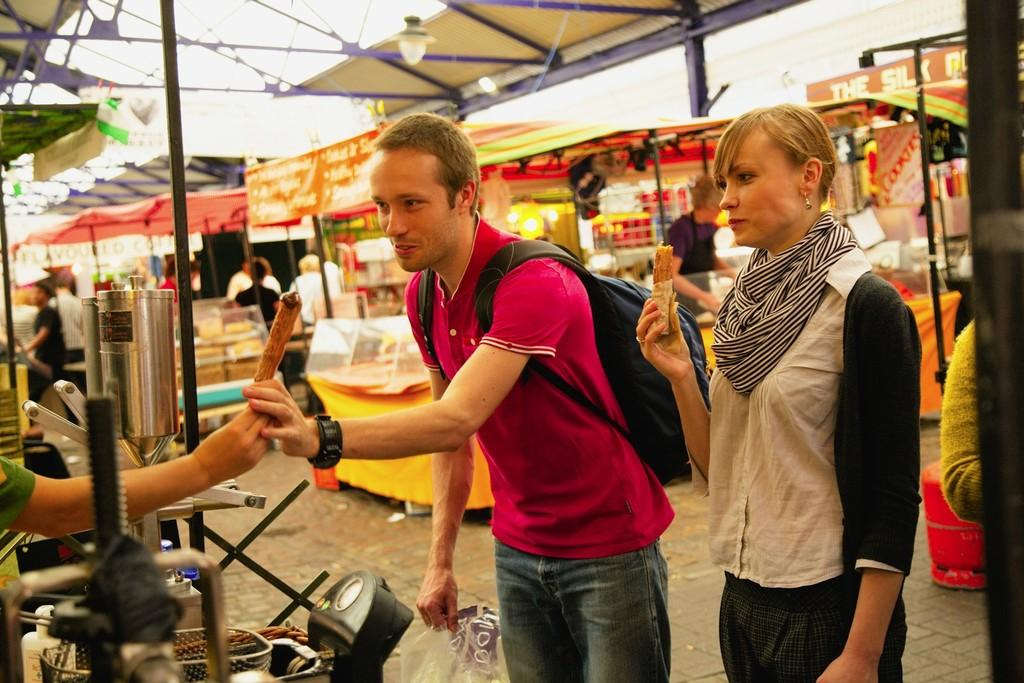What is the girl holding in the image? The girl is holding something named Frankie. What is happening between the girl and the boy in the image? The boy is taking Frankie from the girl's hand. What can be seen in the background of the image? There are food stalls visible in the background. What type of jewel can be seen on the donkey's back in the image? There is no donkey or jewel present in the image. Is there any snow visible in the image? No, there is no snow present in the image. 